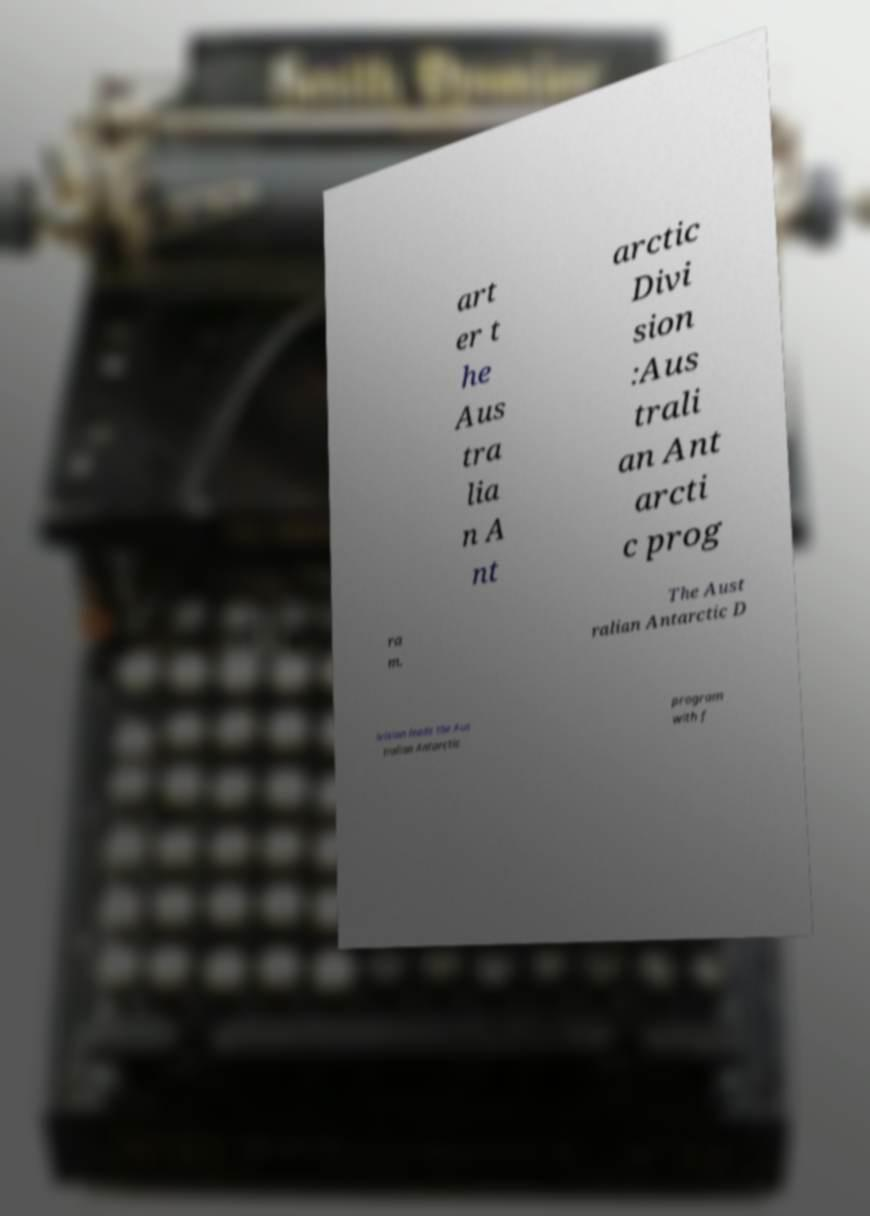There's text embedded in this image that I need extracted. Can you transcribe it verbatim? art er t he Aus tra lia n A nt arctic Divi sion :Aus trali an Ant arcti c prog ra m. The Aust ralian Antarctic D ivision leads the Aus tralian Antarctic program with f 